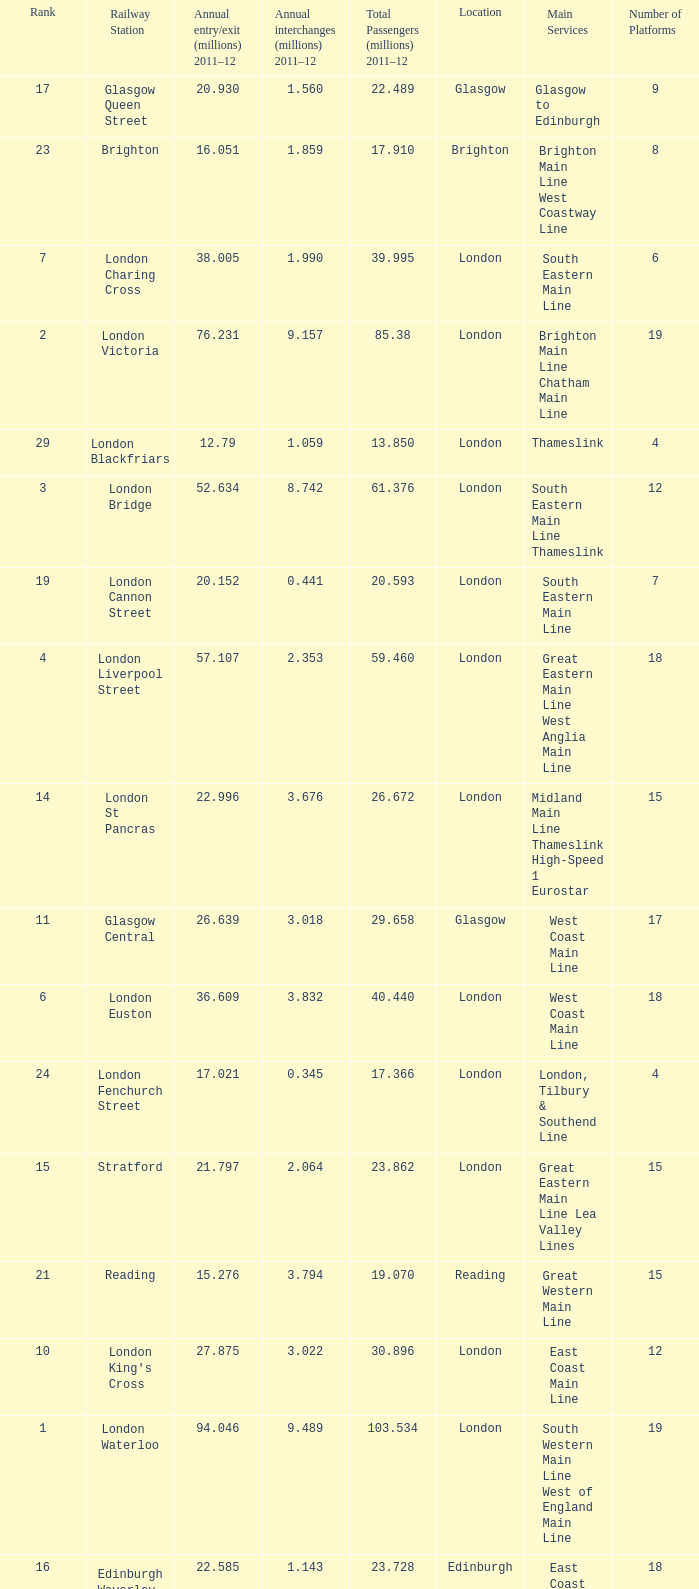How many annual interchanges in the millions occurred in 2011-12 when the number of annual entry/exits was 36.609 million?  3.832. 